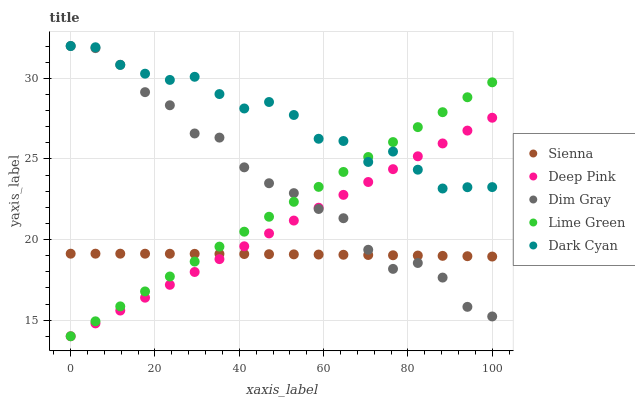Does Sienna have the minimum area under the curve?
Answer yes or no. Yes. Does Dark Cyan have the maximum area under the curve?
Answer yes or no. Yes. Does Dim Gray have the minimum area under the curve?
Answer yes or no. No. Does Dim Gray have the maximum area under the curve?
Answer yes or no. No. Is Deep Pink the smoothest?
Answer yes or no. Yes. Is Dim Gray the roughest?
Answer yes or no. Yes. Is Dark Cyan the smoothest?
Answer yes or no. No. Is Dark Cyan the roughest?
Answer yes or no. No. Does Deep Pink have the lowest value?
Answer yes or no. Yes. Does Dim Gray have the lowest value?
Answer yes or no. No. Does Dim Gray have the highest value?
Answer yes or no. Yes. Does Deep Pink have the highest value?
Answer yes or no. No. Is Sienna less than Dark Cyan?
Answer yes or no. Yes. Is Dark Cyan greater than Sienna?
Answer yes or no. Yes. Does Lime Green intersect Dark Cyan?
Answer yes or no. Yes. Is Lime Green less than Dark Cyan?
Answer yes or no. No. Is Lime Green greater than Dark Cyan?
Answer yes or no. No. Does Sienna intersect Dark Cyan?
Answer yes or no. No. 